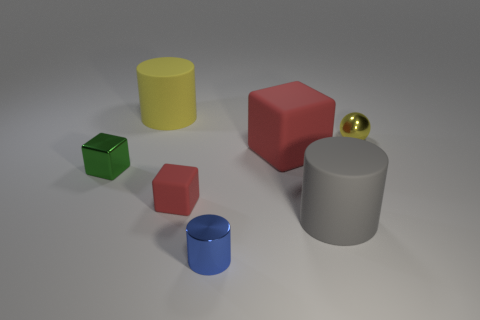There is a metallic thing that is right of the gray cylinder; is it the same size as the large gray cylinder?
Provide a succinct answer. No. What is the size of the yellow object that is the same shape as the blue metal thing?
Offer a very short reply. Large. Are there the same number of metallic things that are behind the large red block and rubber cylinders on the left side of the tiny green shiny object?
Ensure brevity in your answer.  No. There is a yellow thing behind the yellow metal thing; what size is it?
Give a very brief answer. Large. Is the shiny cylinder the same color as the small sphere?
Give a very brief answer. No. Is there anything else that is the same shape as the large red matte thing?
Your response must be concise. Yes. What material is the small object that is the same color as the large block?
Your answer should be compact. Rubber. Are there an equal number of cylinders behind the small blue object and yellow cylinders?
Keep it short and to the point. No. There is a yellow ball; are there any tiny blue things to the right of it?
Give a very brief answer. No. There is a large yellow object; is it the same shape as the matte thing that is to the right of the large cube?
Ensure brevity in your answer.  Yes. 